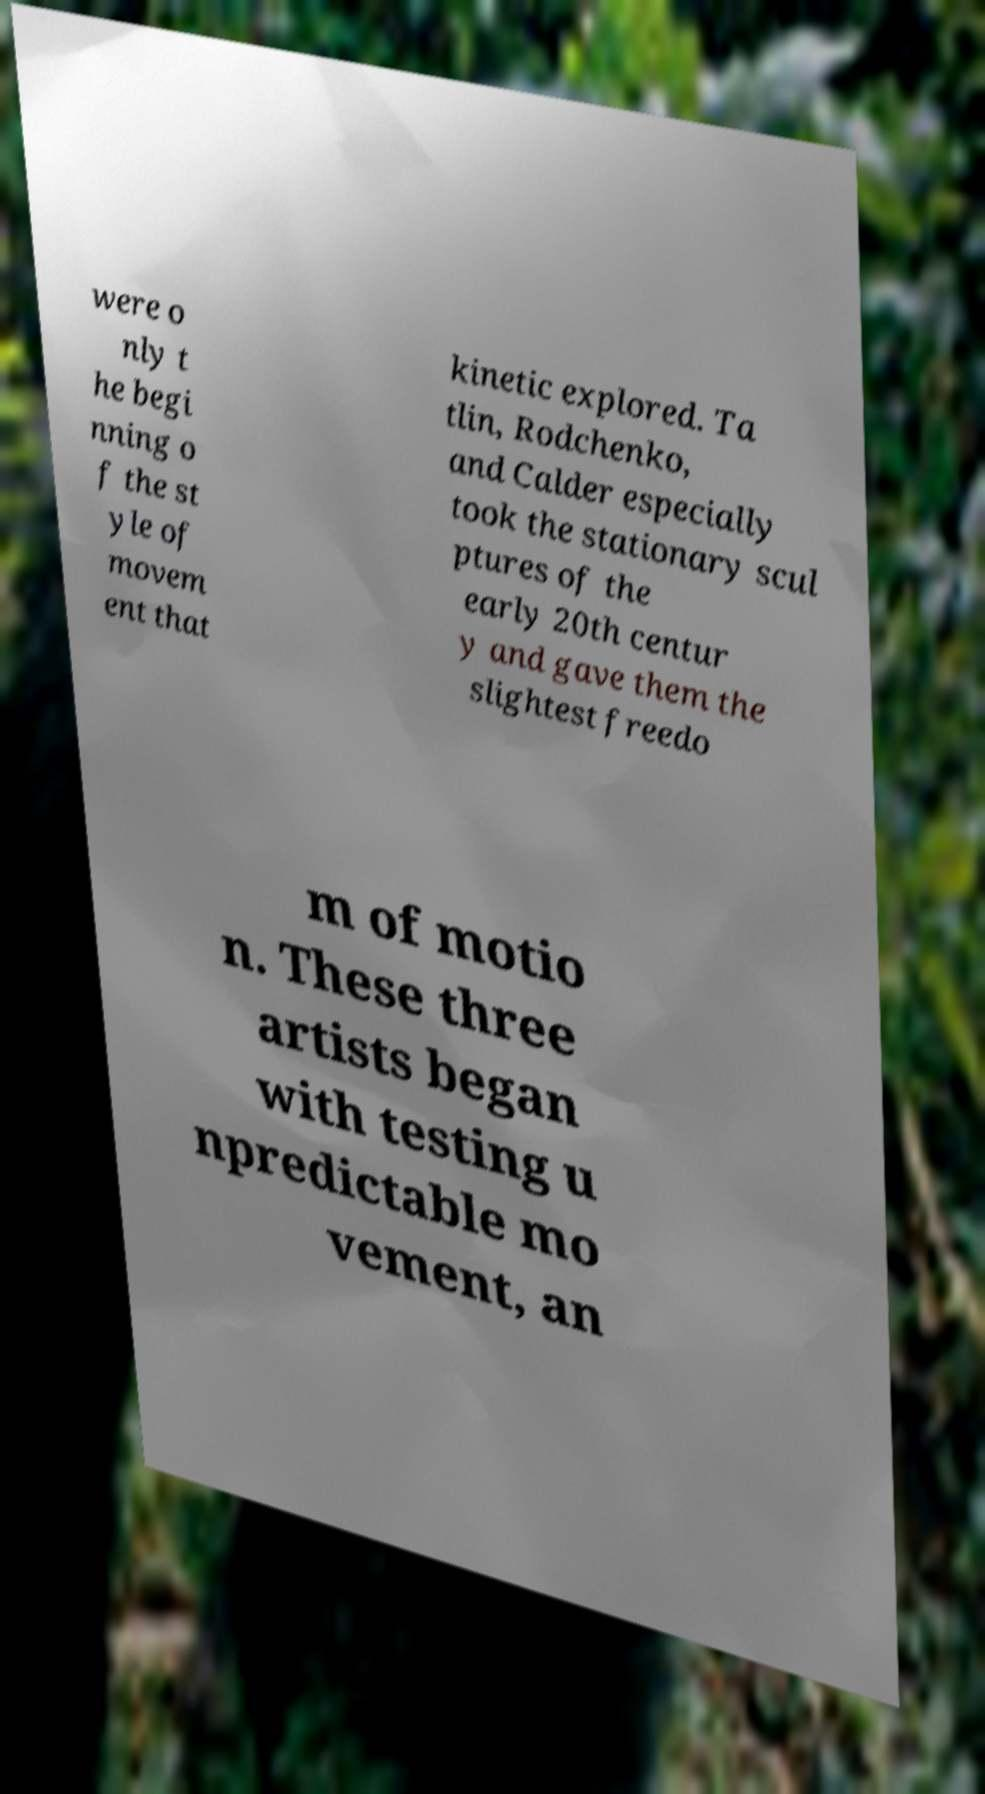Please read and relay the text visible in this image. What does it say? were o nly t he begi nning o f the st yle of movem ent that kinetic explored. Ta tlin, Rodchenko, and Calder especially took the stationary scul ptures of the early 20th centur y and gave them the slightest freedo m of motio n. These three artists began with testing u npredictable mo vement, an 